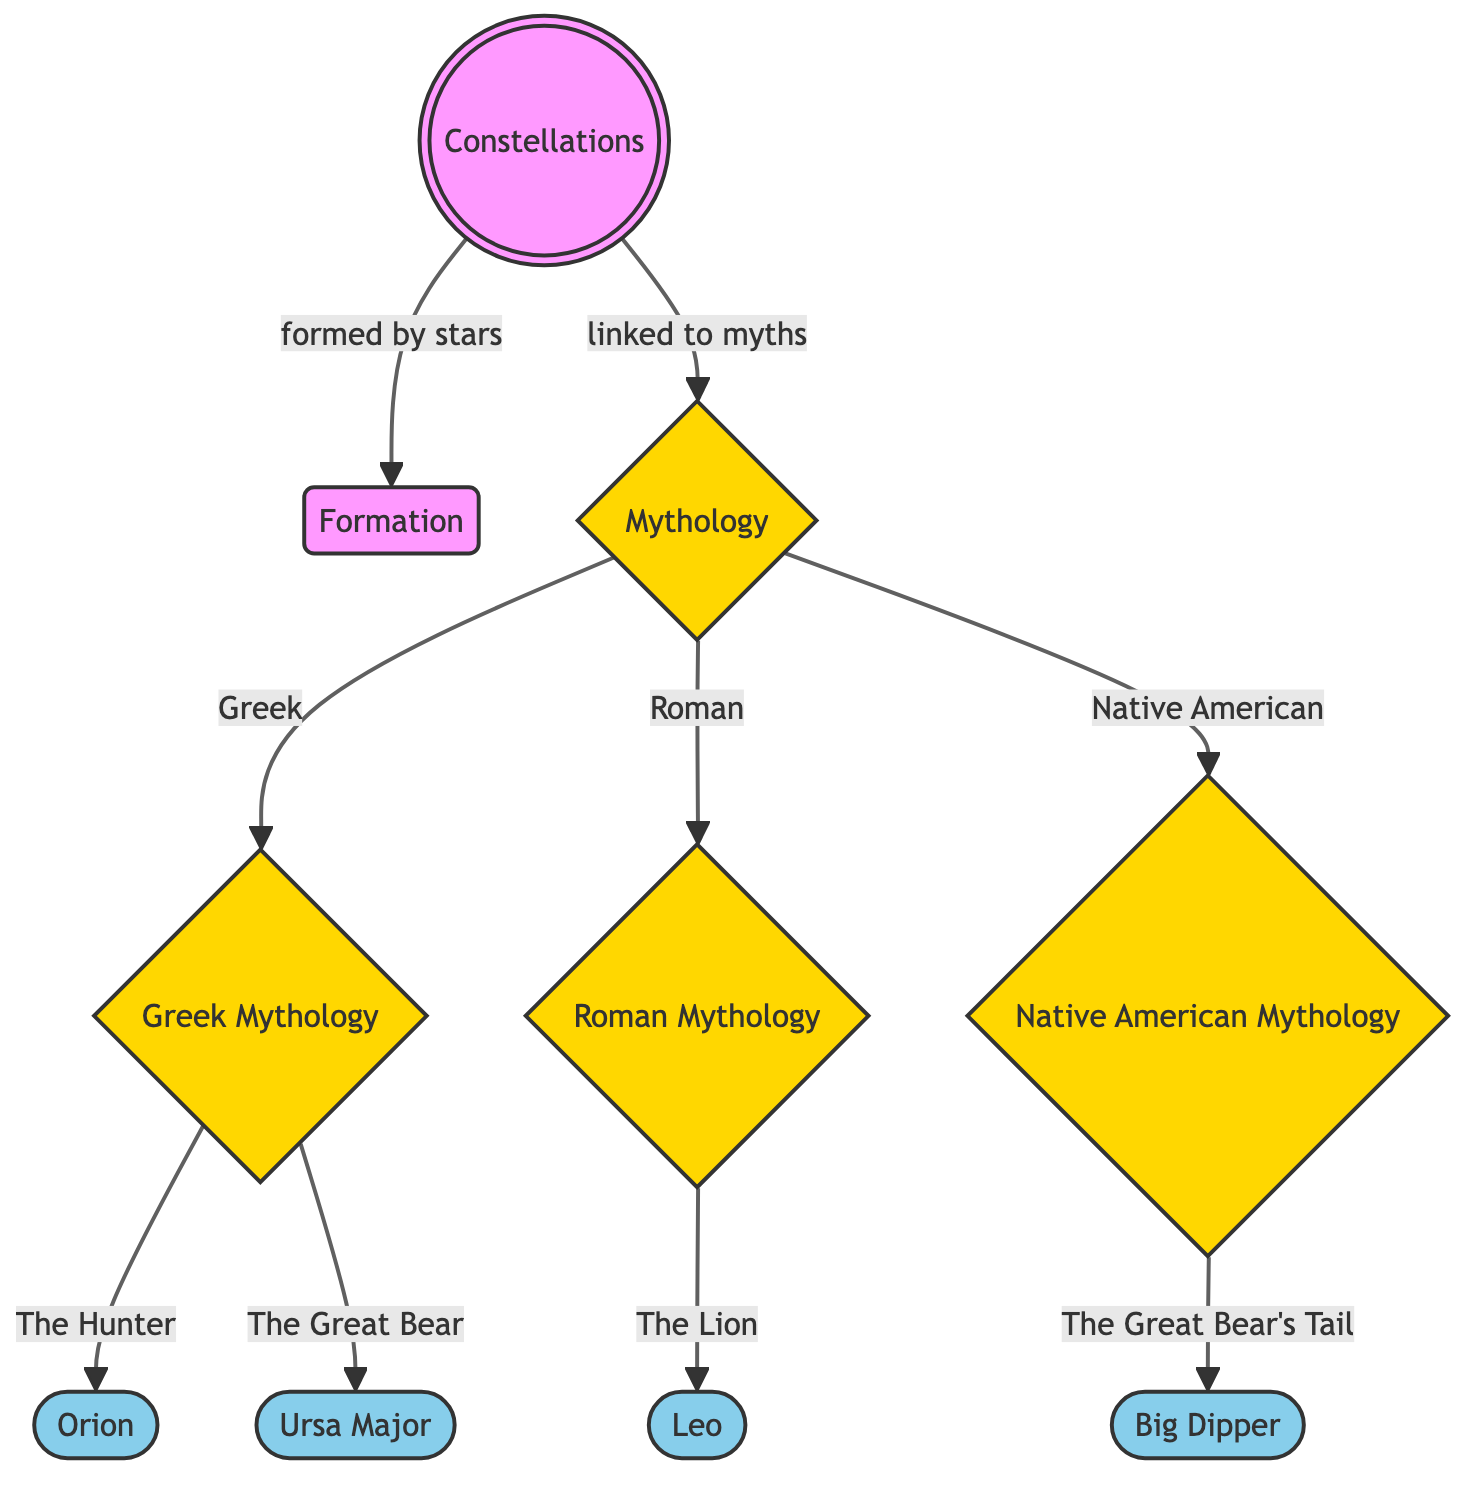What connects constellations and mythology? The diagram shows a direct link between "Constellations" and "Mythology" with the phrase "linked to myths." This indicates that each constellation has an associated mythological story.
Answer: linked to myths How many main branches of mythology are represented in the diagram? The diagram lists three main branches of mythology: Greek Mythology, Roman Mythology, and Native American Mythology, resulting in a total of three branches.
Answer: 3 Which constellation is associated with the Greek mythology characters? The diagram displays that Orion and Ursa Major are specifically linked to Greek mythology, indicating both have significant stories within this cultural context.
Answer: Orion, Ursa Major Which constellation represents the lion in Roman mythology? The diagram directly connects Leo to the Roman mythology as it states "The Lion" refers to this constellation. Hence, Leo is the constellation representing the lion.
Answer: Leo What is the relationship between the Big Dipper and Native American mythology? The linkage in the diagram states that the Big Dipper is associated with "The Great Bear's Tail," demonstrating a specific connection to Native American mythology.
Answer: The Great Bear's Tail Which constellations are depicted under Greek mythology? Under Greek mythology, the diagram illustrates Orion and Ursa Major. Both these constellations are categorized under Greek mythology as per the relationships shown.
Answer: Orion, Ursa Major How many constellations are linked to mythology in total? The diagram lists four constellations: Orion, Ursa Major, Leo, and Big Dipper, confirming that there are four constellations tied to the various mythologies.
Answer: 4 What does the "Formation" node relate to concerning constellations? The arrow connecting "Constellations" to "Formation" with “formed by stars” explains that constellations are created from stars, thus indicating their formation process.
Answer: formed by stars Which mythology suggests a connection to the Great Bear? According to the diagram, both Greek and Native American mythologies reference the bear with Greek mythology linking it to Ursa Major, while Native American mythology specifically refers to it as the Great Bear's Tail.
Answer: Greek, Native American 